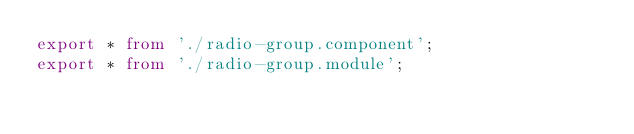<code> <loc_0><loc_0><loc_500><loc_500><_TypeScript_>export * from './radio-group.component';
export * from './radio-group.module';
</code> 